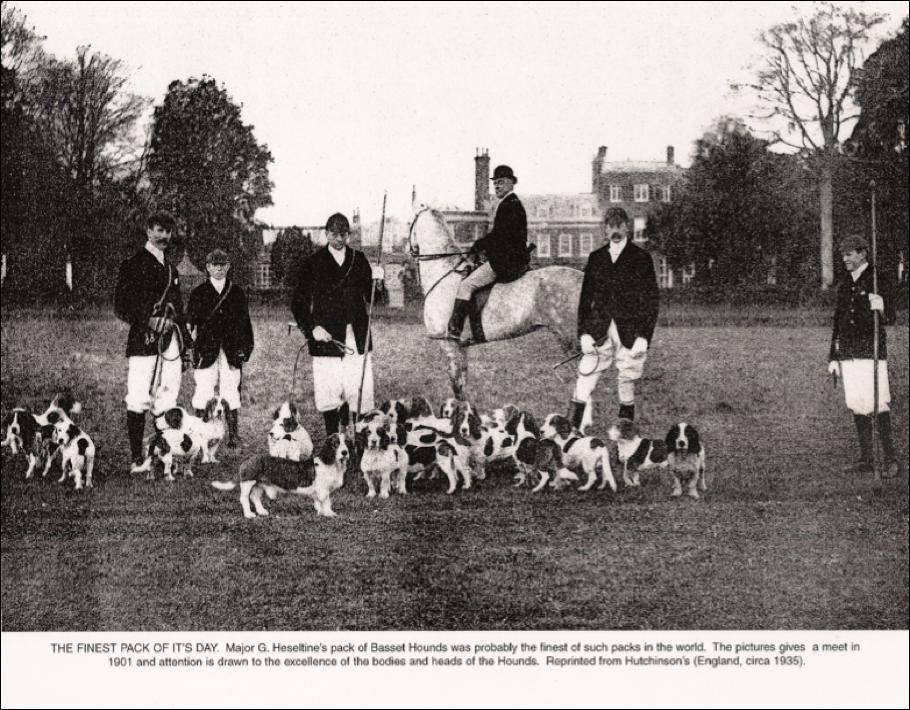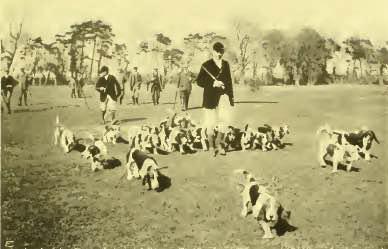The first image is the image on the left, the second image is the image on the right. For the images shown, is this caption "There are no more than eight dogs in the right image." true? Answer yes or no. No. The first image is the image on the left, the second image is the image on the right. For the images displayed, is the sentence "Every single image contains more than one dog." factually correct? Answer yes or no. Yes. 